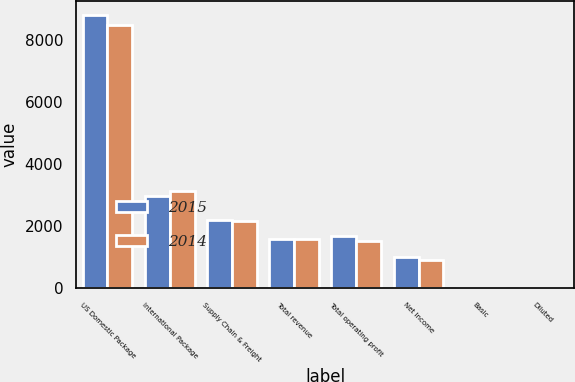Convert chart. <chart><loc_0><loc_0><loc_500><loc_500><stacked_bar_chart><ecel><fcel>US Domestic Package<fcel>International Package<fcel>Supply Chain & Freight<fcel>Total revenue<fcel>Total operating profit<fcel>Net Income<fcel>Basic<fcel>Diluted<nl><fcel>2015<fcel>8814<fcel>2970<fcel>2193<fcel>1593<fcel>1673<fcel>1026<fcel>1.13<fcel>1.12<nl><fcel>2014<fcel>8488<fcel>3127<fcel>2164<fcel>1593<fcel>1513<fcel>911<fcel>0.99<fcel>0.98<nl></chart> 